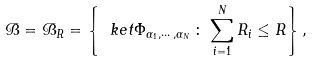Convert formula to latex. <formula><loc_0><loc_0><loc_500><loc_500>\mathcal { B } = \mathcal { B } _ { R } = \left \{ \ k e t { \Phi _ { \alpha _ { 1 } , \cdots , \alpha _ { N } } } \, \colon \, \sum _ { i = 1 } ^ { N } R _ { i } \leq R \right \} ,</formula> 